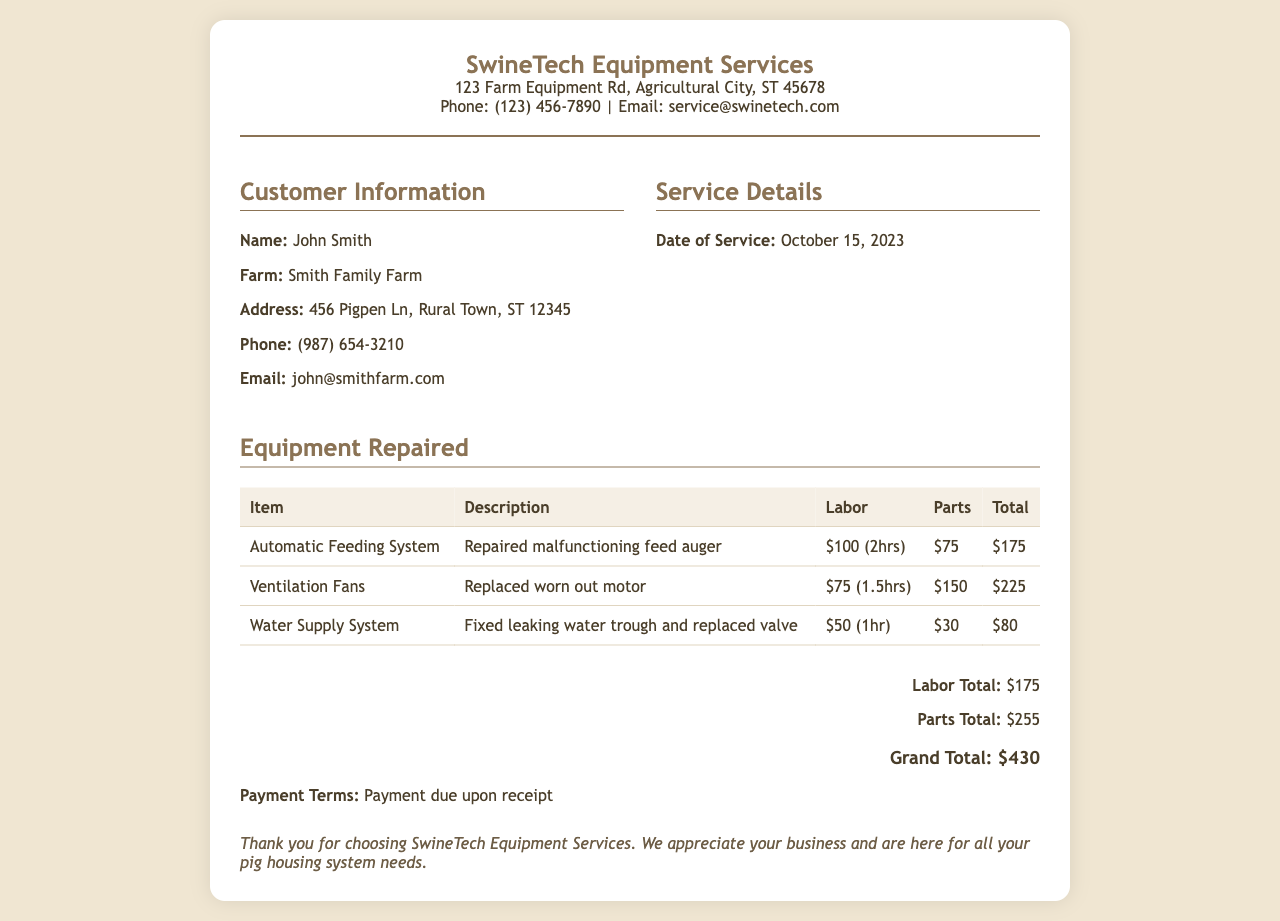What is the name of the service provider? The service provider is identified as SwineTech Equipment Services at the top of the receipt.
Answer: SwineTech Equipment Services Who is the customer? The customer's name is listed in the customer information section.
Answer: John Smith What was the date of service? The date of service is specified in the service details section of the receipt.
Answer: October 15, 2023 How much was the total for labor? The labor total is calculated and provided in the total section of the receipt.
Answer: $175 What was the total amount spent on parts? The parts total is provided separately in the total section of the receipt.
Answer: $255 What is the grand total of the receipt? The grand total is mentioned in the total section, summarizing all costs.
Answer: $430 How long did the repairs on the Automatic Feeding System take? The labor description for that item includes the hours spent on the repair.
Answer: 2hrs What part was replaced for the Ventilation Fans? The description under the Ventilation Fans lists the specific part replaced.
Answer: motor What is the payment term? The payment terms are stated at the end of the receipt, indicating the required timing for payment.
Answer: Payment due upon receipt 